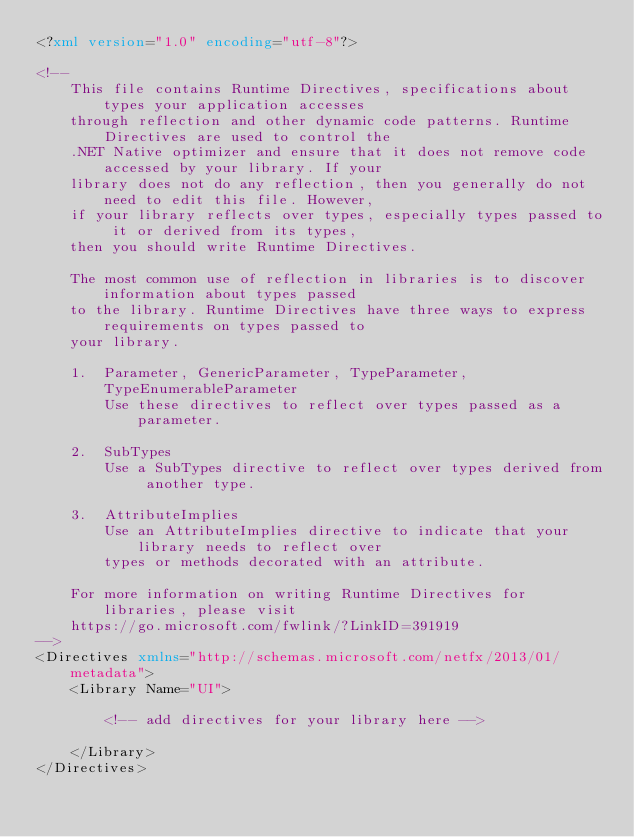Convert code to text. <code><loc_0><loc_0><loc_500><loc_500><_XML_><?xml version="1.0" encoding="utf-8"?>

<!--
    This file contains Runtime Directives, specifications about types your application accesses
    through reflection and other dynamic code patterns. Runtime Directives are used to control the
    .NET Native optimizer and ensure that it does not remove code accessed by your library. If your
    library does not do any reflection, then you generally do not need to edit this file. However,
    if your library reflects over types, especially types passed to it or derived from its types,
    then you should write Runtime Directives.

    The most common use of reflection in libraries is to discover information about types passed
    to the library. Runtime Directives have three ways to express requirements on types passed to
    your library.

    1.  Parameter, GenericParameter, TypeParameter, TypeEnumerableParameter
        Use these directives to reflect over types passed as a parameter.

    2.  SubTypes
        Use a SubTypes directive to reflect over types derived from another type.

    3.  AttributeImplies
        Use an AttributeImplies directive to indicate that your library needs to reflect over
        types or methods decorated with an attribute.

    For more information on writing Runtime Directives for libraries, please visit
    https://go.microsoft.com/fwlink/?LinkID=391919
-->
<Directives xmlns="http://schemas.microsoft.com/netfx/2013/01/metadata">
    <Library Name="UI">

        <!-- add directives for your library here -->

    </Library>
</Directives>
</code> 